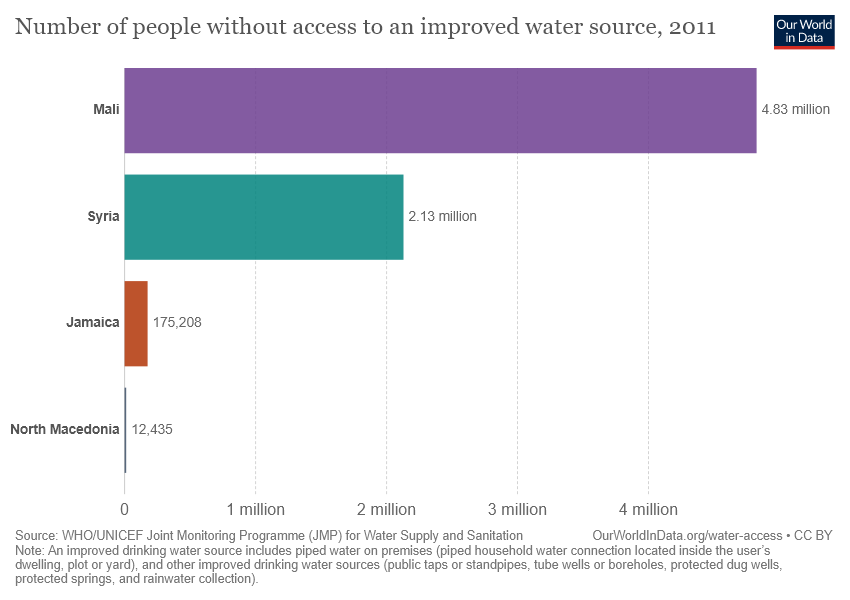Outline some significant characteristics in this image. In Syria, an estimated 2.13 million people do not have access to improved water sources, indicating a significant lack of access to clean and safe water for the population. 